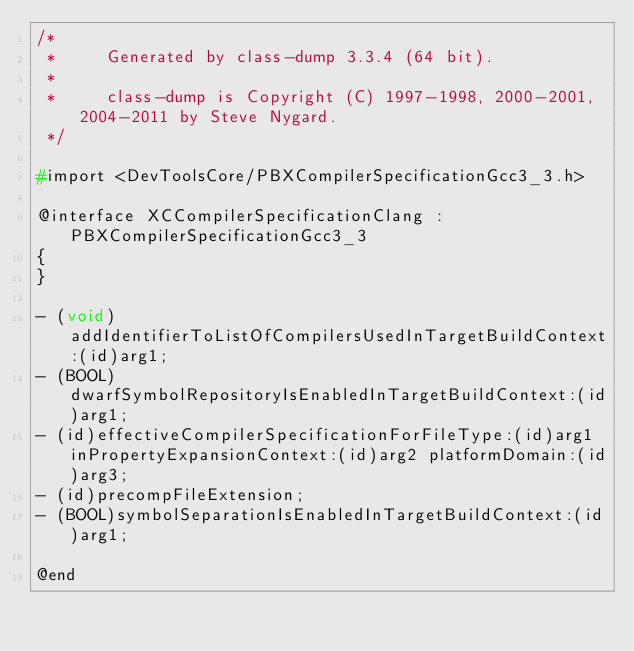Convert code to text. <code><loc_0><loc_0><loc_500><loc_500><_C_>/*
 *     Generated by class-dump 3.3.4 (64 bit).
 *
 *     class-dump is Copyright (C) 1997-1998, 2000-2001, 2004-2011 by Steve Nygard.
 */

#import <DevToolsCore/PBXCompilerSpecificationGcc3_3.h>

@interface XCCompilerSpecificationClang : PBXCompilerSpecificationGcc3_3
{
}

- (void)addIdentifierToListOfCompilersUsedInTargetBuildContext:(id)arg1;
- (BOOL)dwarfSymbolRepositoryIsEnabledInTargetBuildContext:(id)arg1;
- (id)effectiveCompilerSpecificationForFileType:(id)arg1 inPropertyExpansionContext:(id)arg2 platformDomain:(id)arg3;
- (id)precompFileExtension;
- (BOOL)symbolSeparationIsEnabledInTargetBuildContext:(id)arg1;

@end

</code> 